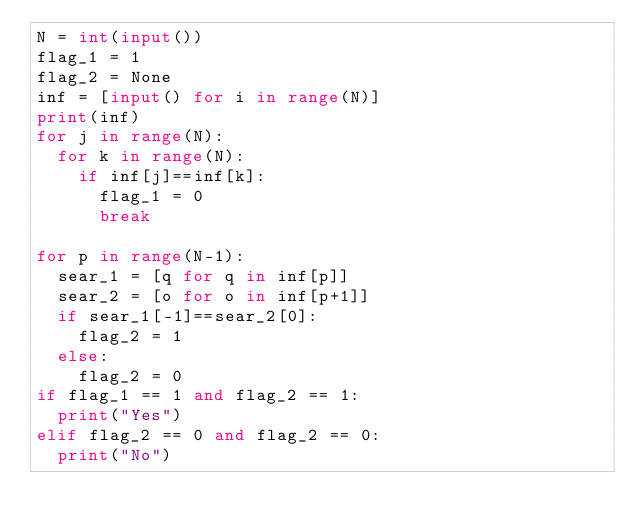Convert code to text. <code><loc_0><loc_0><loc_500><loc_500><_Python_>N = int(input())
flag_1 = 1
flag_2 = None
inf = [input() for i in range(N)]
print(inf)
for j in range(N):
  for k in range(N):
    if inf[j]==inf[k]:
      flag_1 = 0
      break

for p in range(N-1):
  sear_1 = [q for q in inf[p]]
  sear_2 = [o for o in inf[p+1]]
  if sear_1[-1]==sear_2[0]:
    flag_2 = 1
  else:
    flag_2 = 0
if flag_1 == 1 and flag_2 == 1:
  print("Yes")
elif flag_2 == 0 and flag_2 == 0:
  print("No")
    </code> 